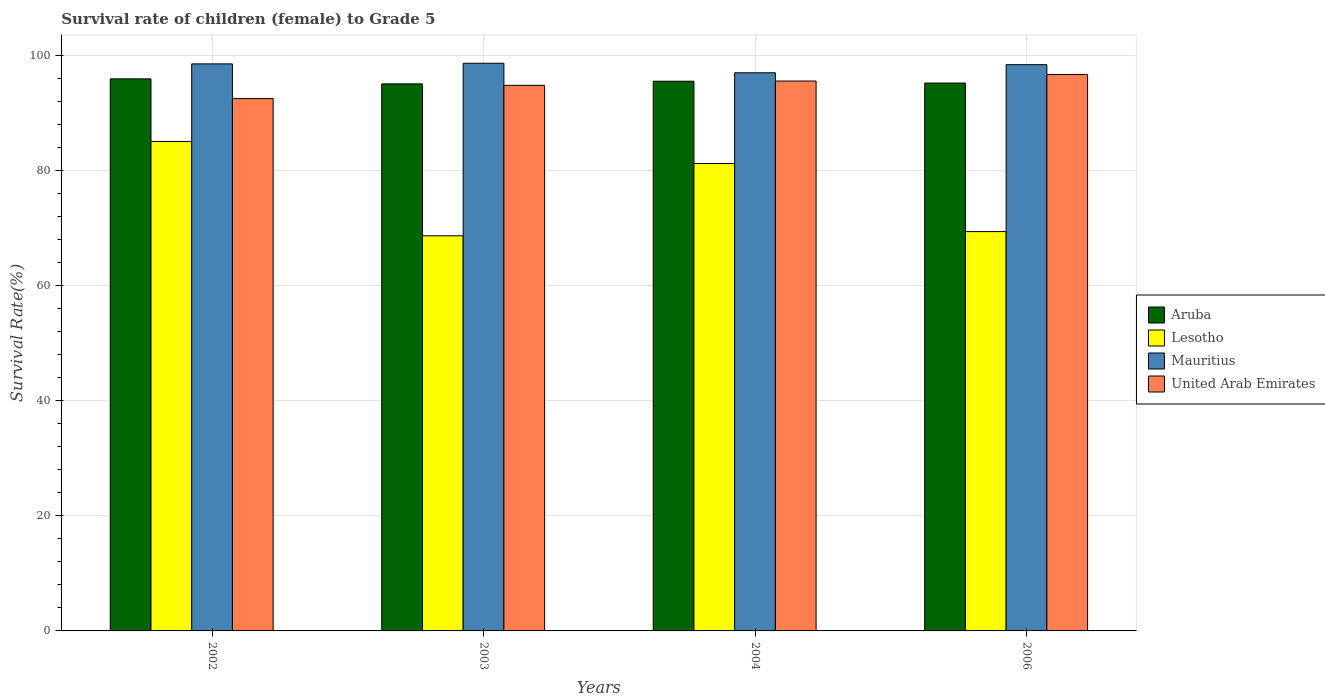How many different coloured bars are there?
Offer a terse response. 4. How many groups of bars are there?
Provide a short and direct response. 4. How many bars are there on the 4th tick from the right?
Your answer should be compact. 4. What is the label of the 3rd group of bars from the left?
Your answer should be compact. 2004. In how many cases, is the number of bars for a given year not equal to the number of legend labels?
Provide a succinct answer. 0. What is the survival rate of female children to grade 5 in United Arab Emirates in 2004?
Offer a very short reply. 95.54. Across all years, what is the maximum survival rate of female children to grade 5 in Mauritius?
Your response must be concise. 98.63. Across all years, what is the minimum survival rate of female children to grade 5 in United Arab Emirates?
Offer a terse response. 92.49. In which year was the survival rate of female children to grade 5 in Aruba maximum?
Provide a short and direct response. 2002. In which year was the survival rate of female children to grade 5 in Lesotho minimum?
Your response must be concise. 2003. What is the total survival rate of female children to grade 5 in Aruba in the graph?
Your answer should be very brief. 381.66. What is the difference between the survival rate of female children to grade 5 in Lesotho in 2004 and that in 2006?
Provide a succinct answer. 11.83. What is the difference between the survival rate of female children to grade 5 in Aruba in 2003 and the survival rate of female children to grade 5 in Lesotho in 2004?
Offer a very short reply. 13.84. What is the average survival rate of female children to grade 5 in Lesotho per year?
Offer a terse response. 76.07. In the year 2004, what is the difference between the survival rate of female children to grade 5 in Mauritius and survival rate of female children to grade 5 in United Arab Emirates?
Offer a terse response. 1.44. What is the ratio of the survival rate of female children to grade 5 in Lesotho in 2004 to that in 2006?
Keep it short and to the point. 1.17. Is the difference between the survival rate of female children to grade 5 in Mauritius in 2002 and 2006 greater than the difference between the survival rate of female children to grade 5 in United Arab Emirates in 2002 and 2006?
Your response must be concise. Yes. What is the difference between the highest and the second highest survival rate of female children to grade 5 in United Arab Emirates?
Give a very brief answer. 1.14. What is the difference between the highest and the lowest survival rate of female children to grade 5 in United Arab Emirates?
Provide a short and direct response. 4.19. Is the sum of the survival rate of female children to grade 5 in United Arab Emirates in 2004 and 2006 greater than the maximum survival rate of female children to grade 5 in Lesotho across all years?
Offer a very short reply. Yes. What does the 3rd bar from the left in 2003 represents?
Provide a short and direct response. Mauritius. What does the 4th bar from the right in 2002 represents?
Make the answer very short. Aruba. How many bars are there?
Offer a terse response. 16. What is the difference between two consecutive major ticks on the Y-axis?
Ensure brevity in your answer.  20. Are the values on the major ticks of Y-axis written in scientific E-notation?
Give a very brief answer. No. Does the graph contain grids?
Ensure brevity in your answer.  Yes. How are the legend labels stacked?
Give a very brief answer. Vertical. What is the title of the graph?
Ensure brevity in your answer.  Survival rate of children (female) to Grade 5. Does "Korea (Democratic)" appear as one of the legend labels in the graph?
Offer a very short reply. No. What is the label or title of the X-axis?
Keep it short and to the point. Years. What is the label or title of the Y-axis?
Make the answer very short. Survival Rate(%). What is the Survival Rate(%) of Aruba in 2002?
Provide a short and direct response. 95.92. What is the Survival Rate(%) of Lesotho in 2002?
Your answer should be compact. 85.04. What is the Survival Rate(%) of Mauritius in 2002?
Keep it short and to the point. 98.52. What is the Survival Rate(%) of United Arab Emirates in 2002?
Provide a short and direct response. 92.49. What is the Survival Rate(%) in Aruba in 2003?
Offer a very short reply. 95.05. What is the Survival Rate(%) of Lesotho in 2003?
Your answer should be very brief. 68.65. What is the Survival Rate(%) of Mauritius in 2003?
Make the answer very short. 98.63. What is the Survival Rate(%) of United Arab Emirates in 2003?
Keep it short and to the point. 94.8. What is the Survival Rate(%) of Aruba in 2004?
Keep it short and to the point. 95.51. What is the Survival Rate(%) in Lesotho in 2004?
Your answer should be very brief. 81.21. What is the Survival Rate(%) of Mauritius in 2004?
Provide a succinct answer. 96.98. What is the Survival Rate(%) of United Arab Emirates in 2004?
Make the answer very short. 95.54. What is the Survival Rate(%) in Aruba in 2006?
Ensure brevity in your answer.  95.19. What is the Survival Rate(%) of Lesotho in 2006?
Offer a terse response. 69.38. What is the Survival Rate(%) in Mauritius in 2006?
Provide a short and direct response. 98.39. What is the Survival Rate(%) of United Arab Emirates in 2006?
Provide a short and direct response. 96.68. Across all years, what is the maximum Survival Rate(%) of Aruba?
Offer a terse response. 95.92. Across all years, what is the maximum Survival Rate(%) in Lesotho?
Your response must be concise. 85.04. Across all years, what is the maximum Survival Rate(%) of Mauritius?
Your answer should be very brief. 98.63. Across all years, what is the maximum Survival Rate(%) in United Arab Emirates?
Your response must be concise. 96.68. Across all years, what is the minimum Survival Rate(%) in Aruba?
Give a very brief answer. 95.05. Across all years, what is the minimum Survival Rate(%) in Lesotho?
Provide a succinct answer. 68.65. Across all years, what is the minimum Survival Rate(%) of Mauritius?
Give a very brief answer. 96.98. Across all years, what is the minimum Survival Rate(%) of United Arab Emirates?
Provide a succinct answer. 92.49. What is the total Survival Rate(%) of Aruba in the graph?
Offer a terse response. 381.67. What is the total Survival Rate(%) of Lesotho in the graph?
Provide a succinct answer. 304.29. What is the total Survival Rate(%) of Mauritius in the graph?
Offer a terse response. 392.52. What is the total Survival Rate(%) of United Arab Emirates in the graph?
Keep it short and to the point. 379.51. What is the difference between the Survival Rate(%) of Aruba in 2002 and that in 2003?
Offer a terse response. 0.87. What is the difference between the Survival Rate(%) in Lesotho in 2002 and that in 2003?
Make the answer very short. 16.39. What is the difference between the Survival Rate(%) in Mauritius in 2002 and that in 2003?
Ensure brevity in your answer.  -0.11. What is the difference between the Survival Rate(%) of United Arab Emirates in 2002 and that in 2003?
Offer a very short reply. -2.31. What is the difference between the Survival Rate(%) in Aruba in 2002 and that in 2004?
Your response must be concise. 0.41. What is the difference between the Survival Rate(%) of Lesotho in 2002 and that in 2004?
Offer a very short reply. 3.84. What is the difference between the Survival Rate(%) of Mauritius in 2002 and that in 2004?
Your answer should be very brief. 1.54. What is the difference between the Survival Rate(%) in United Arab Emirates in 2002 and that in 2004?
Provide a short and direct response. -3.06. What is the difference between the Survival Rate(%) in Aruba in 2002 and that in 2006?
Offer a very short reply. 0.73. What is the difference between the Survival Rate(%) in Lesotho in 2002 and that in 2006?
Give a very brief answer. 15.66. What is the difference between the Survival Rate(%) of Mauritius in 2002 and that in 2006?
Ensure brevity in your answer.  0.13. What is the difference between the Survival Rate(%) of United Arab Emirates in 2002 and that in 2006?
Offer a terse response. -4.19. What is the difference between the Survival Rate(%) of Aruba in 2003 and that in 2004?
Make the answer very short. -0.46. What is the difference between the Survival Rate(%) of Lesotho in 2003 and that in 2004?
Ensure brevity in your answer.  -12.56. What is the difference between the Survival Rate(%) in Mauritius in 2003 and that in 2004?
Offer a terse response. 1.65. What is the difference between the Survival Rate(%) of United Arab Emirates in 2003 and that in 2004?
Provide a short and direct response. -0.75. What is the difference between the Survival Rate(%) in Aruba in 2003 and that in 2006?
Offer a terse response. -0.15. What is the difference between the Survival Rate(%) of Lesotho in 2003 and that in 2006?
Give a very brief answer. -0.73. What is the difference between the Survival Rate(%) of Mauritius in 2003 and that in 2006?
Your answer should be compact. 0.24. What is the difference between the Survival Rate(%) of United Arab Emirates in 2003 and that in 2006?
Provide a short and direct response. -1.89. What is the difference between the Survival Rate(%) in Aruba in 2004 and that in 2006?
Give a very brief answer. 0.32. What is the difference between the Survival Rate(%) in Lesotho in 2004 and that in 2006?
Ensure brevity in your answer.  11.83. What is the difference between the Survival Rate(%) in Mauritius in 2004 and that in 2006?
Offer a very short reply. -1.41. What is the difference between the Survival Rate(%) in United Arab Emirates in 2004 and that in 2006?
Offer a terse response. -1.14. What is the difference between the Survival Rate(%) in Aruba in 2002 and the Survival Rate(%) in Lesotho in 2003?
Keep it short and to the point. 27.27. What is the difference between the Survival Rate(%) in Aruba in 2002 and the Survival Rate(%) in Mauritius in 2003?
Your answer should be very brief. -2.71. What is the difference between the Survival Rate(%) of Aruba in 2002 and the Survival Rate(%) of United Arab Emirates in 2003?
Your answer should be compact. 1.12. What is the difference between the Survival Rate(%) in Lesotho in 2002 and the Survival Rate(%) in Mauritius in 2003?
Offer a very short reply. -13.59. What is the difference between the Survival Rate(%) in Lesotho in 2002 and the Survival Rate(%) in United Arab Emirates in 2003?
Your answer should be compact. -9.75. What is the difference between the Survival Rate(%) in Mauritius in 2002 and the Survival Rate(%) in United Arab Emirates in 2003?
Your answer should be very brief. 3.73. What is the difference between the Survival Rate(%) in Aruba in 2002 and the Survival Rate(%) in Lesotho in 2004?
Provide a short and direct response. 14.71. What is the difference between the Survival Rate(%) in Aruba in 2002 and the Survival Rate(%) in Mauritius in 2004?
Offer a terse response. -1.06. What is the difference between the Survival Rate(%) of Aruba in 2002 and the Survival Rate(%) of United Arab Emirates in 2004?
Ensure brevity in your answer.  0.37. What is the difference between the Survival Rate(%) in Lesotho in 2002 and the Survival Rate(%) in Mauritius in 2004?
Ensure brevity in your answer.  -11.94. What is the difference between the Survival Rate(%) in Lesotho in 2002 and the Survival Rate(%) in United Arab Emirates in 2004?
Your answer should be compact. -10.5. What is the difference between the Survival Rate(%) in Mauritius in 2002 and the Survival Rate(%) in United Arab Emirates in 2004?
Provide a short and direct response. 2.98. What is the difference between the Survival Rate(%) of Aruba in 2002 and the Survival Rate(%) of Lesotho in 2006?
Provide a short and direct response. 26.54. What is the difference between the Survival Rate(%) in Aruba in 2002 and the Survival Rate(%) in Mauritius in 2006?
Offer a very short reply. -2.47. What is the difference between the Survival Rate(%) in Aruba in 2002 and the Survival Rate(%) in United Arab Emirates in 2006?
Your answer should be very brief. -0.76. What is the difference between the Survival Rate(%) of Lesotho in 2002 and the Survival Rate(%) of Mauritius in 2006?
Your answer should be compact. -13.34. What is the difference between the Survival Rate(%) of Lesotho in 2002 and the Survival Rate(%) of United Arab Emirates in 2006?
Provide a succinct answer. -11.64. What is the difference between the Survival Rate(%) of Mauritius in 2002 and the Survival Rate(%) of United Arab Emirates in 2006?
Give a very brief answer. 1.84. What is the difference between the Survival Rate(%) in Aruba in 2003 and the Survival Rate(%) in Lesotho in 2004?
Keep it short and to the point. 13.84. What is the difference between the Survival Rate(%) in Aruba in 2003 and the Survival Rate(%) in Mauritius in 2004?
Keep it short and to the point. -1.93. What is the difference between the Survival Rate(%) of Aruba in 2003 and the Survival Rate(%) of United Arab Emirates in 2004?
Your answer should be compact. -0.5. What is the difference between the Survival Rate(%) in Lesotho in 2003 and the Survival Rate(%) in Mauritius in 2004?
Ensure brevity in your answer.  -28.33. What is the difference between the Survival Rate(%) in Lesotho in 2003 and the Survival Rate(%) in United Arab Emirates in 2004?
Provide a succinct answer. -26.89. What is the difference between the Survival Rate(%) of Mauritius in 2003 and the Survival Rate(%) of United Arab Emirates in 2004?
Your answer should be compact. 3.09. What is the difference between the Survival Rate(%) in Aruba in 2003 and the Survival Rate(%) in Lesotho in 2006?
Ensure brevity in your answer.  25.66. What is the difference between the Survival Rate(%) in Aruba in 2003 and the Survival Rate(%) in Mauritius in 2006?
Make the answer very short. -3.34. What is the difference between the Survival Rate(%) in Aruba in 2003 and the Survival Rate(%) in United Arab Emirates in 2006?
Provide a succinct answer. -1.64. What is the difference between the Survival Rate(%) of Lesotho in 2003 and the Survival Rate(%) of Mauritius in 2006?
Ensure brevity in your answer.  -29.74. What is the difference between the Survival Rate(%) of Lesotho in 2003 and the Survival Rate(%) of United Arab Emirates in 2006?
Make the answer very short. -28.03. What is the difference between the Survival Rate(%) in Mauritius in 2003 and the Survival Rate(%) in United Arab Emirates in 2006?
Provide a succinct answer. 1.95. What is the difference between the Survival Rate(%) in Aruba in 2004 and the Survival Rate(%) in Lesotho in 2006?
Offer a very short reply. 26.13. What is the difference between the Survival Rate(%) of Aruba in 2004 and the Survival Rate(%) of Mauritius in 2006?
Your response must be concise. -2.88. What is the difference between the Survival Rate(%) of Aruba in 2004 and the Survival Rate(%) of United Arab Emirates in 2006?
Your answer should be very brief. -1.17. What is the difference between the Survival Rate(%) in Lesotho in 2004 and the Survival Rate(%) in Mauritius in 2006?
Your answer should be compact. -17.18. What is the difference between the Survival Rate(%) of Lesotho in 2004 and the Survival Rate(%) of United Arab Emirates in 2006?
Your answer should be very brief. -15.47. What is the difference between the Survival Rate(%) in Mauritius in 2004 and the Survival Rate(%) in United Arab Emirates in 2006?
Your answer should be very brief. 0.3. What is the average Survival Rate(%) in Aruba per year?
Ensure brevity in your answer.  95.42. What is the average Survival Rate(%) in Lesotho per year?
Your response must be concise. 76.07. What is the average Survival Rate(%) in Mauritius per year?
Keep it short and to the point. 98.13. What is the average Survival Rate(%) in United Arab Emirates per year?
Give a very brief answer. 94.88. In the year 2002, what is the difference between the Survival Rate(%) of Aruba and Survival Rate(%) of Lesotho?
Offer a very short reply. 10.87. In the year 2002, what is the difference between the Survival Rate(%) of Aruba and Survival Rate(%) of Mauritius?
Make the answer very short. -2.6. In the year 2002, what is the difference between the Survival Rate(%) of Aruba and Survival Rate(%) of United Arab Emirates?
Provide a short and direct response. 3.43. In the year 2002, what is the difference between the Survival Rate(%) in Lesotho and Survival Rate(%) in Mauritius?
Offer a very short reply. -13.48. In the year 2002, what is the difference between the Survival Rate(%) in Lesotho and Survival Rate(%) in United Arab Emirates?
Offer a terse response. -7.44. In the year 2002, what is the difference between the Survival Rate(%) in Mauritius and Survival Rate(%) in United Arab Emirates?
Offer a terse response. 6.03. In the year 2003, what is the difference between the Survival Rate(%) in Aruba and Survival Rate(%) in Lesotho?
Offer a terse response. 26.39. In the year 2003, what is the difference between the Survival Rate(%) in Aruba and Survival Rate(%) in Mauritius?
Make the answer very short. -3.59. In the year 2003, what is the difference between the Survival Rate(%) in Aruba and Survival Rate(%) in United Arab Emirates?
Provide a short and direct response. 0.25. In the year 2003, what is the difference between the Survival Rate(%) of Lesotho and Survival Rate(%) of Mauritius?
Offer a terse response. -29.98. In the year 2003, what is the difference between the Survival Rate(%) in Lesotho and Survival Rate(%) in United Arab Emirates?
Offer a very short reply. -26.14. In the year 2003, what is the difference between the Survival Rate(%) in Mauritius and Survival Rate(%) in United Arab Emirates?
Your answer should be compact. 3.84. In the year 2004, what is the difference between the Survival Rate(%) in Aruba and Survival Rate(%) in Lesotho?
Offer a very short reply. 14.3. In the year 2004, what is the difference between the Survival Rate(%) of Aruba and Survival Rate(%) of Mauritius?
Make the answer very short. -1.47. In the year 2004, what is the difference between the Survival Rate(%) in Aruba and Survival Rate(%) in United Arab Emirates?
Ensure brevity in your answer.  -0.03. In the year 2004, what is the difference between the Survival Rate(%) in Lesotho and Survival Rate(%) in Mauritius?
Give a very brief answer. -15.77. In the year 2004, what is the difference between the Survival Rate(%) in Lesotho and Survival Rate(%) in United Arab Emirates?
Offer a terse response. -14.34. In the year 2004, what is the difference between the Survival Rate(%) of Mauritius and Survival Rate(%) of United Arab Emirates?
Your answer should be very brief. 1.44. In the year 2006, what is the difference between the Survival Rate(%) in Aruba and Survival Rate(%) in Lesotho?
Provide a short and direct response. 25.81. In the year 2006, what is the difference between the Survival Rate(%) of Aruba and Survival Rate(%) of Mauritius?
Keep it short and to the point. -3.2. In the year 2006, what is the difference between the Survival Rate(%) in Aruba and Survival Rate(%) in United Arab Emirates?
Make the answer very short. -1.49. In the year 2006, what is the difference between the Survival Rate(%) of Lesotho and Survival Rate(%) of Mauritius?
Give a very brief answer. -29.01. In the year 2006, what is the difference between the Survival Rate(%) of Lesotho and Survival Rate(%) of United Arab Emirates?
Keep it short and to the point. -27.3. In the year 2006, what is the difference between the Survival Rate(%) of Mauritius and Survival Rate(%) of United Arab Emirates?
Give a very brief answer. 1.71. What is the ratio of the Survival Rate(%) of Aruba in 2002 to that in 2003?
Provide a succinct answer. 1.01. What is the ratio of the Survival Rate(%) in Lesotho in 2002 to that in 2003?
Provide a short and direct response. 1.24. What is the ratio of the Survival Rate(%) in Mauritius in 2002 to that in 2003?
Ensure brevity in your answer.  1. What is the ratio of the Survival Rate(%) of United Arab Emirates in 2002 to that in 2003?
Offer a very short reply. 0.98. What is the ratio of the Survival Rate(%) of Aruba in 2002 to that in 2004?
Offer a very short reply. 1. What is the ratio of the Survival Rate(%) of Lesotho in 2002 to that in 2004?
Your answer should be very brief. 1.05. What is the ratio of the Survival Rate(%) in Mauritius in 2002 to that in 2004?
Keep it short and to the point. 1.02. What is the ratio of the Survival Rate(%) of Aruba in 2002 to that in 2006?
Ensure brevity in your answer.  1.01. What is the ratio of the Survival Rate(%) of Lesotho in 2002 to that in 2006?
Your answer should be very brief. 1.23. What is the ratio of the Survival Rate(%) of Mauritius in 2002 to that in 2006?
Offer a very short reply. 1. What is the ratio of the Survival Rate(%) in United Arab Emirates in 2002 to that in 2006?
Provide a succinct answer. 0.96. What is the ratio of the Survival Rate(%) in Aruba in 2003 to that in 2004?
Your answer should be very brief. 1. What is the ratio of the Survival Rate(%) in Lesotho in 2003 to that in 2004?
Provide a short and direct response. 0.85. What is the ratio of the Survival Rate(%) in Mauritius in 2003 to that in 2004?
Offer a very short reply. 1.02. What is the ratio of the Survival Rate(%) of Aruba in 2003 to that in 2006?
Give a very brief answer. 1. What is the ratio of the Survival Rate(%) of Mauritius in 2003 to that in 2006?
Offer a very short reply. 1. What is the ratio of the Survival Rate(%) in United Arab Emirates in 2003 to that in 2006?
Keep it short and to the point. 0.98. What is the ratio of the Survival Rate(%) of Aruba in 2004 to that in 2006?
Provide a short and direct response. 1. What is the ratio of the Survival Rate(%) of Lesotho in 2004 to that in 2006?
Offer a terse response. 1.17. What is the ratio of the Survival Rate(%) of Mauritius in 2004 to that in 2006?
Your answer should be compact. 0.99. What is the ratio of the Survival Rate(%) of United Arab Emirates in 2004 to that in 2006?
Offer a very short reply. 0.99. What is the difference between the highest and the second highest Survival Rate(%) of Aruba?
Offer a terse response. 0.41. What is the difference between the highest and the second highest Survival Rate(%) in Lesotho?
Your answer should be very brief. 3.84. What is the difference between the highest and the second highest Survival Rate(%) of Mauritius?
Provide a short and direct response. 0.11. What is the difference between the highest and the second highest Survival Rate(%) of United Arab Emirates?
Your answer should be very brief. 1.14. What is the difference between the highest and the lowest Survival Rate(%) of Aruba?
Your answer should be very brief. 0.87. What is the difference between the highest and the lowest Survival Rate(%) of Lesotho?
Give a very brief answer. 16.39. What is the difference between the highest and the lowest Survival Rate(%) of Mauritius?
Your answer should be very brief. 1.65. What is the difference between the highest and the lowest Survival Rate(%) in United Arab Emirates?
Keep it short and to the point. 4.19. 